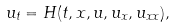<formula> <loc_0><loc_0><loc_500><loc_500>u _ { t } = H ( t , x , u , u _ { x } , u _ { x x } ) ,</formula> 